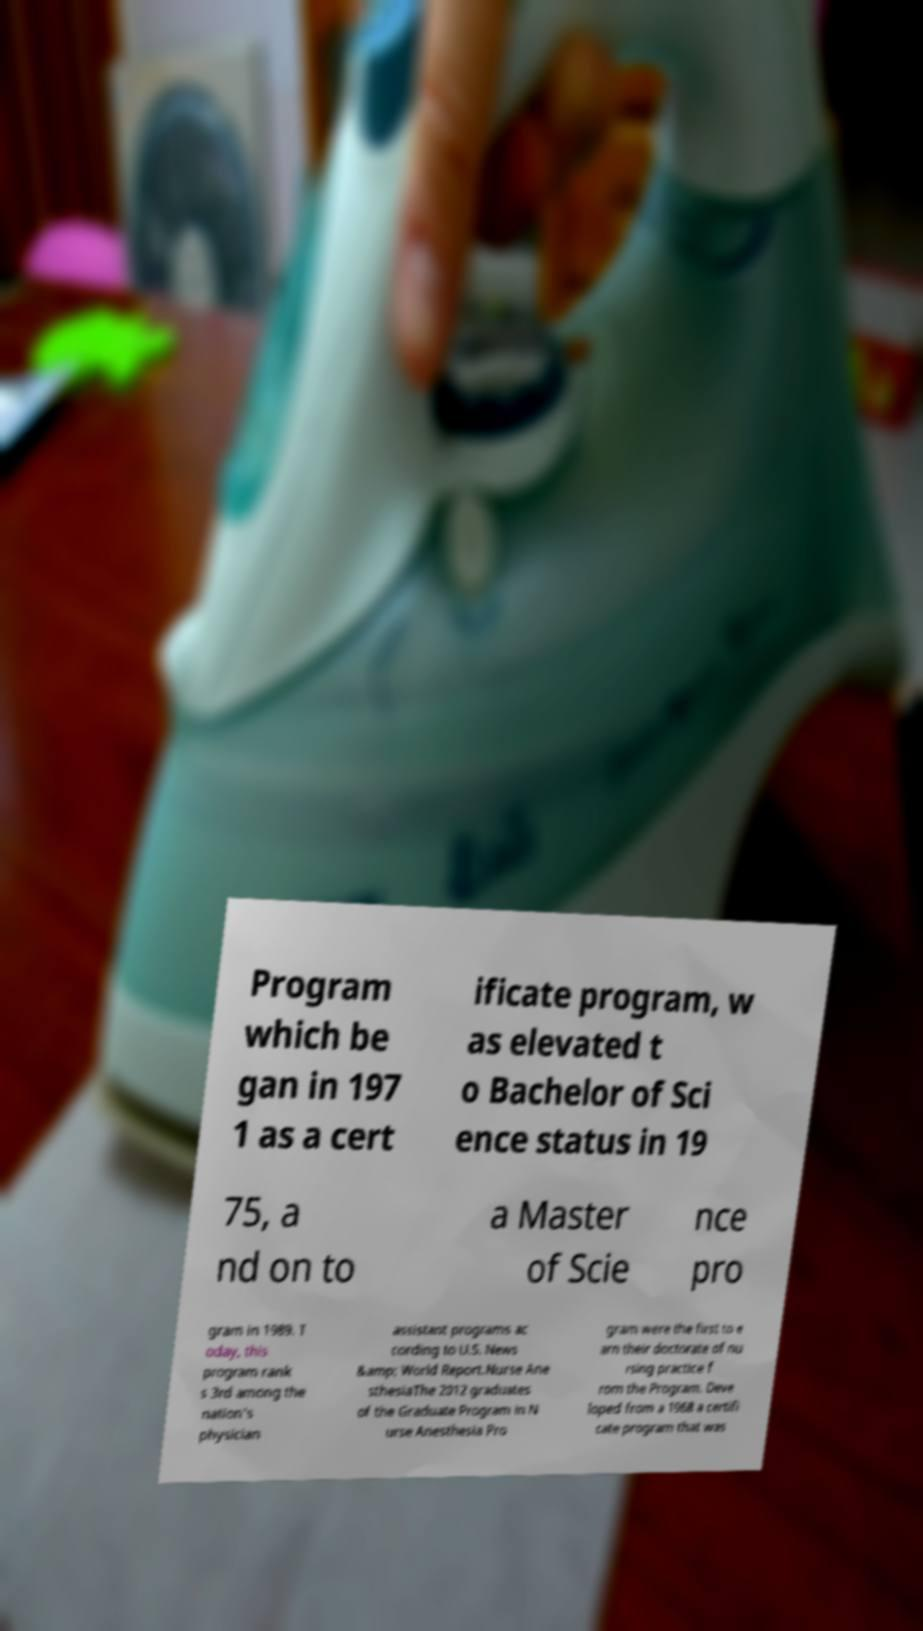I need the written content from this picture converted into text. Can you do that? Program which be gan in 197 1 as a cert ificate program, w as elevated t o Bachelor of Sci ence status in 19 75, a nd on to a Master of Scie nce pro gram in 1989. T oday, this program rank s 3rd among the nation's physician assistant programs ac cording to U.S. News &amp; World Report.Nurse Ane sthesiaThe 2012 graduates of the Graduate Program in N urse Anesthesia Pro gram were the first to e arn their doctorate of nu rsing practice f rom the Program. Deve loped from a 1968 a certifi cate program that was 